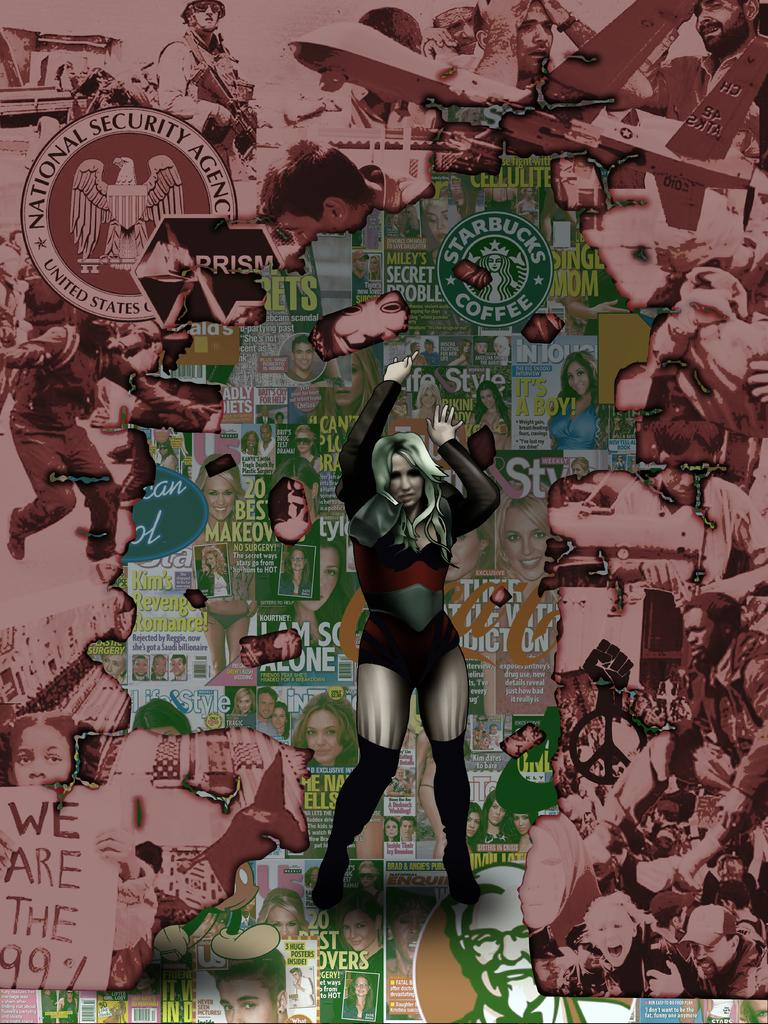Provide a one-sentence caption for the provided image. a magazine that has the word sty on it. 